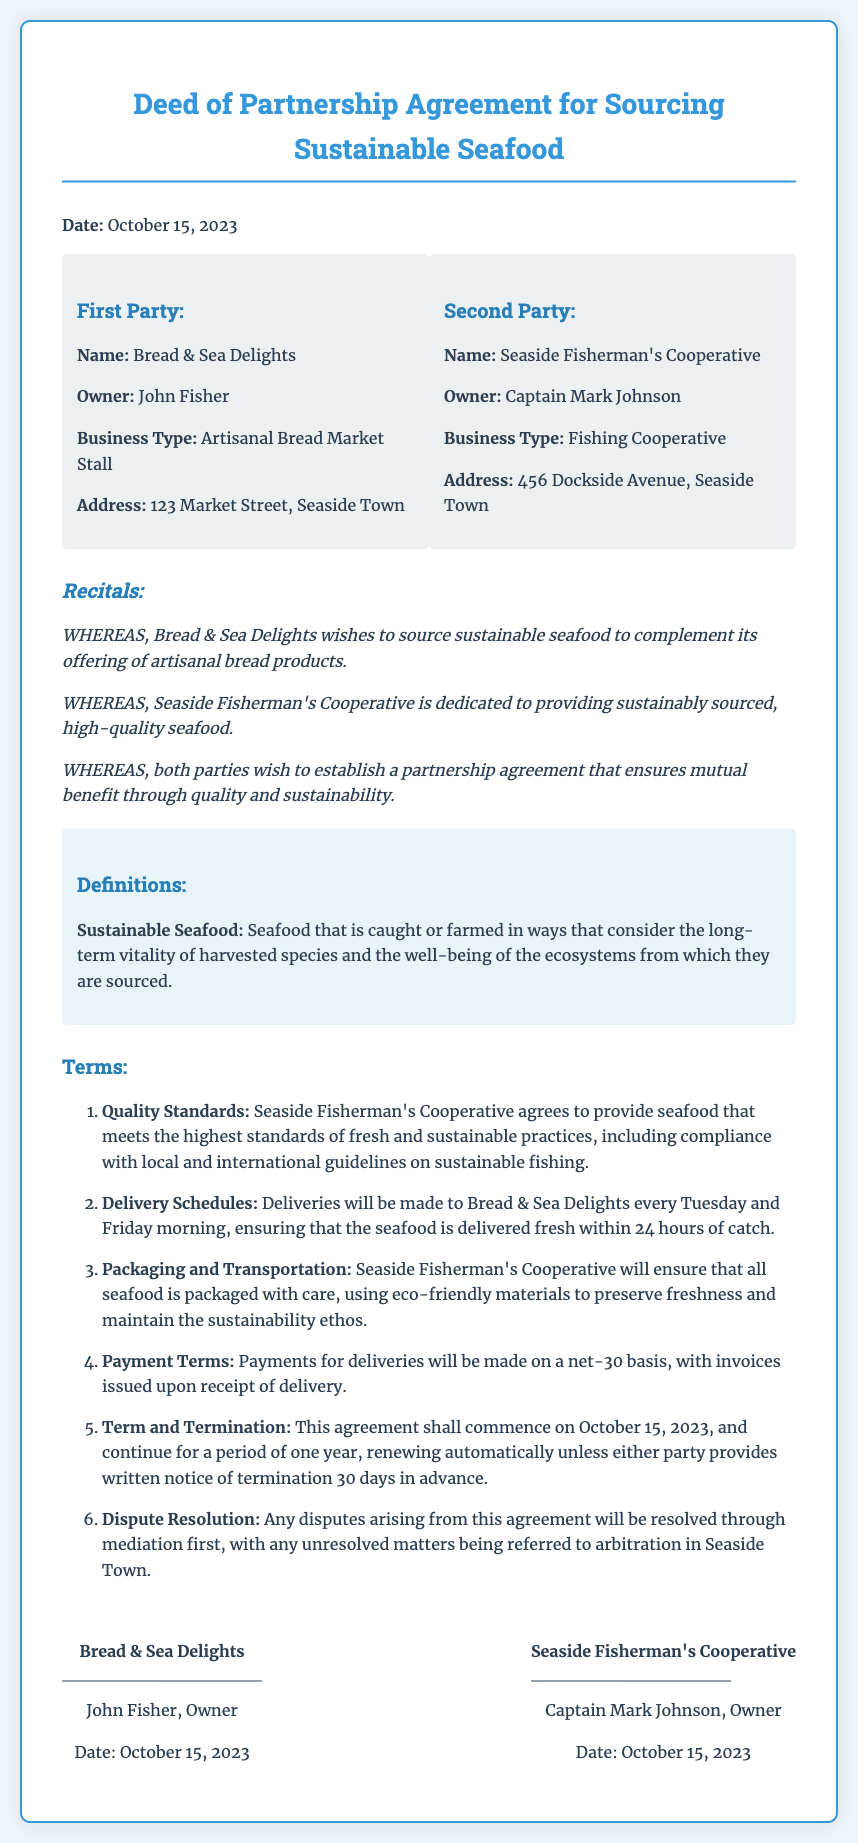What is the date of the agreement? The date of the agreement is stated prominently near the beginning of the document.
Answer: October 15, 2023 Who is the owner of Bread & Sea Delights? This information can be found in the section that lists the first party's details.
Answer: John Fisher What are the delivery days specified in the agreement? The delivery days are outlined in the terms section addressing delivery schedules.
Answer: Tuesday and Friday What is the payment term mentioned in the document? This information is detailed in the terms associated with payment.
Answer: net-30 What is the definition of sustainable seafood provided in the document? The document includes a definitions section that specifies the term.
Answer: Seafood that is caught or farmed in ways that consider the long-term vitality of harvested species and the well-being of ecosystems How long is the initial term of the agreement? The document clearly states the duration of the agreement in the terms section.
Answer: one year Who is the owner of Seaside Fisherman's Cooperative? The document lists the owner as part of the second party's details.
Answer: Captain Mark Johnson What is the address of Bread & Sea Delights? This information can be found in the party details section of the document.
Answer: 123 Market Street, Seaside Town What is the method for resolving disputes according to the document? The terms section outlines how disputes are to be handled, providing insight into the resolution process.
Answer: mediation first 